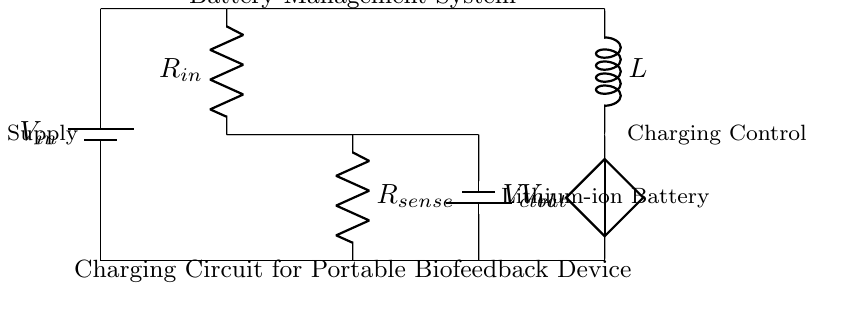What is the power supply voltage? The power supply voltage is labeled as V in the circuit and is the voltage that provides energy to the charging circuit.
Answer: V in What type of battery is used in this circuit? The circuit diagram illustrates that a lithium-ion battery is connected, indicating the type of battery used for the energy storage.
Answer: Lithium-ion battery What component senses current in the circuit? The resistor labeled as R sense is the component responsible for current sensing, as it is specifically designed for that purpose in battery management systems.
Answer: R sense What is the function of the component labeled as L? The component labeled as L is an inductor, which is typically used to manage the charging process, including smoothing current and filtering voltage for efficiency in battery charging.
Answer: Inductor What is the overall purpose of this circuit? The circuit is designed to manage the charging of a portable biofeedback device's battery, ensuring safe and efficient operation, particularly in addiction treatment devices that rely on consistent power for functionality.
Answer: Battery management system Which component provides control voltage in the circuit? The control voltage is provided by the component labeled as V ctrl, which is responsible for regulating the charging process and ensuring proper functioning of the battery management system.
Answer: V ctrl What is the role of R in this circuit? The resistor labeled as R in the circuit functions primarily as an input resistor, which helps to limit the current entering the circuit, protecting sensitive components from excessive current.
Answer: R in 